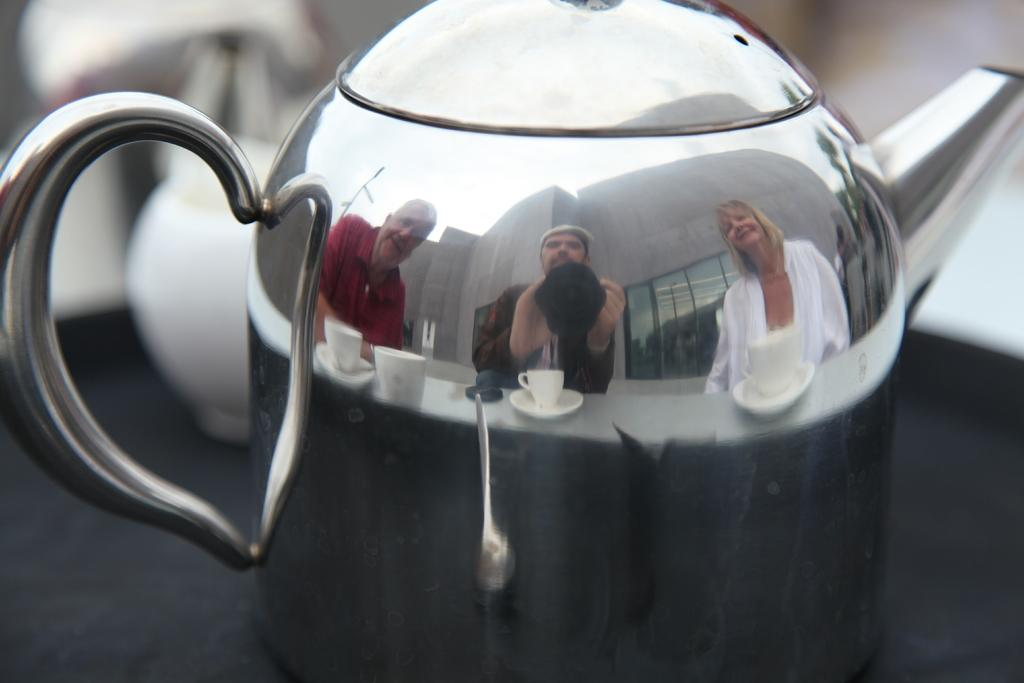What object is the main focus of the image? There is a teapot in the image. What can be seen on the surface of the teapot? There is a reflection of three persons on the teapot. What other objects are visible in the reflection on the teapot? Cups and saucers are visible in the reflection on the teapot. How would you describe the background of the image? The background of the image is blurry. What type of orange is being peeled by the daughter in the image? There is no daughter or orange present in the image; it features a teapot with a reflection of three persons and cups and saucers. 